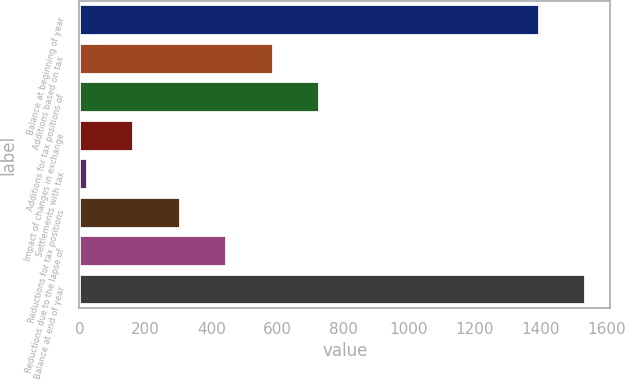Convert chart to OTSL. <chart><loc_0><loc_0><loc_500><loc_500><bar_chart><fcel>Balance at beginning of year<fcel>Additions based on tax<fcel>Additions for tax positions of<fcel>Impact of changes in exchange<fcel>Settlements with tax<fcel>Reductions for tax positions<fcel>Reductions due to the lapse of<fcel>Balance at end of year<nl><fcel>1393<fcel>586.4<fcel>727.5<fcel>163.1<fcel>22<fcel>304.2<fcel>445.3<fcel>1534.1<nl></chart> 